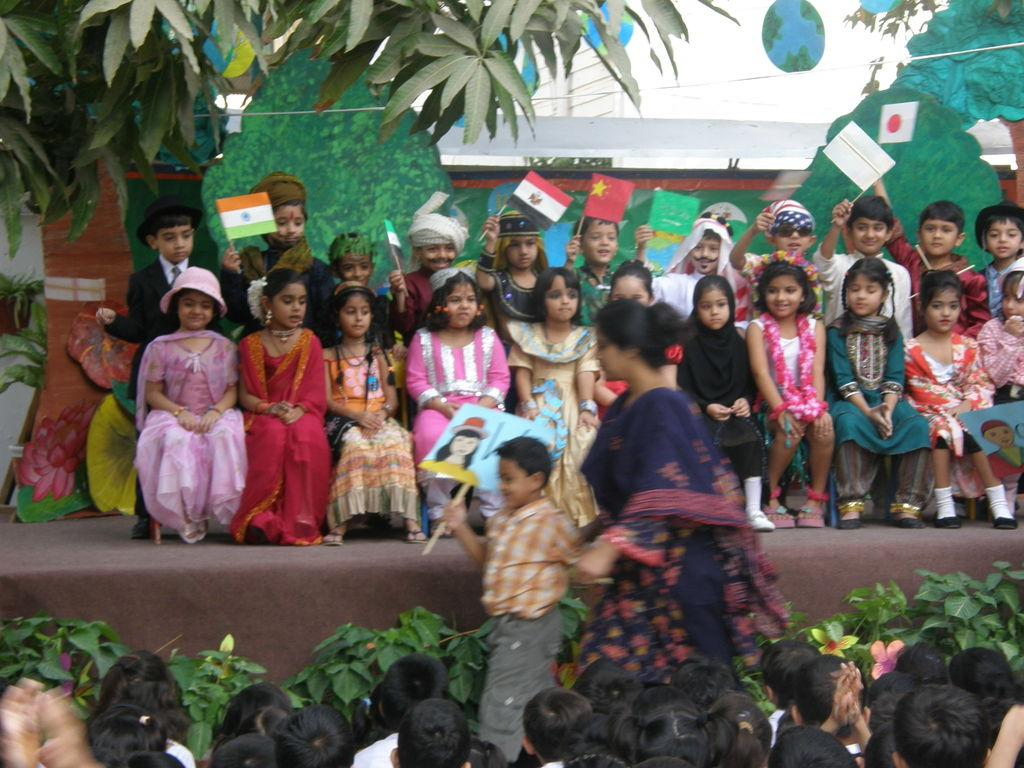What is happening with the group of children in the image? The group of children is sitting on a stage. Who is standing in front of the stage? A woman is standing in front of the stage. What can be seen in the background of the image? There is a tree, a building, a group of plants, and the sky visible in the background of the image. What type of fowl can be seen flying in the image? There is no fowl visible in the image. What sound can be heard coming from the children on the stage? The image is a still picture, so no sound can be heard. 